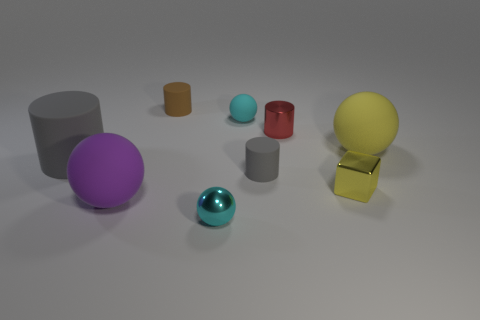Which objects in the image are the largest and the smallest by volume? The largest object by volume appears to be the yellow ball on the right, and the smallest by volume is the tiny cyan matte ball near the center. 